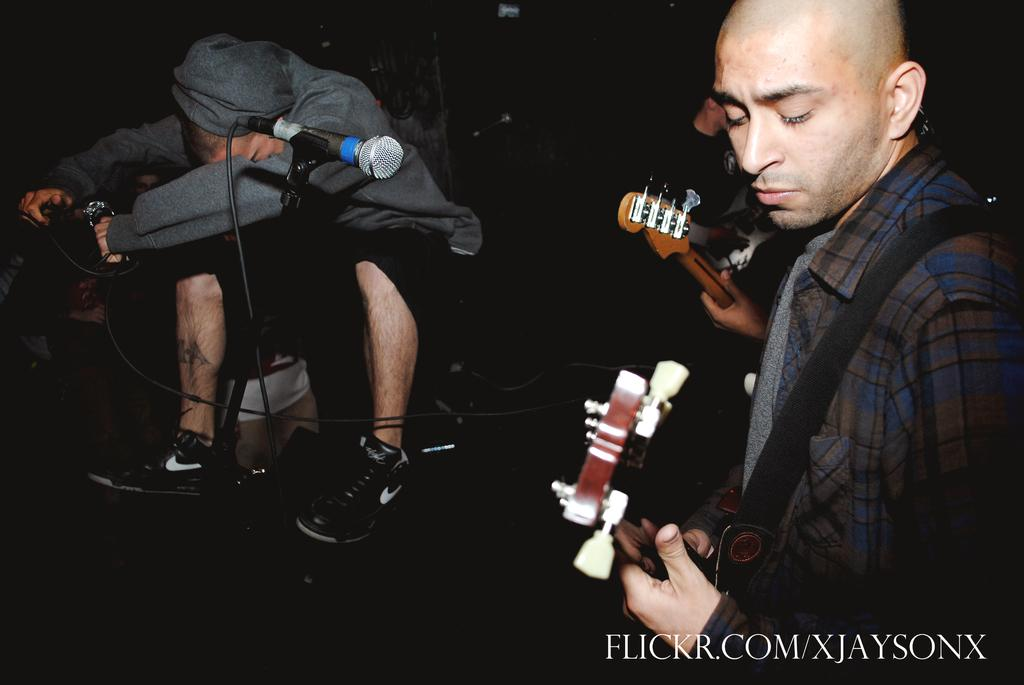What is the color of the background in the image? The background of the image is dark. What is the man in the image doing? The man is sitting in the image. What object is present in the image that is typically used for amplifying sound? There is a microphone in the image. What are the two people standing in the image doing? Both standing people are playing guitars. What type of exchange is taking place between the baby and the microphone in the image? There is no baby present in the image, so no such exchange can be observed. 